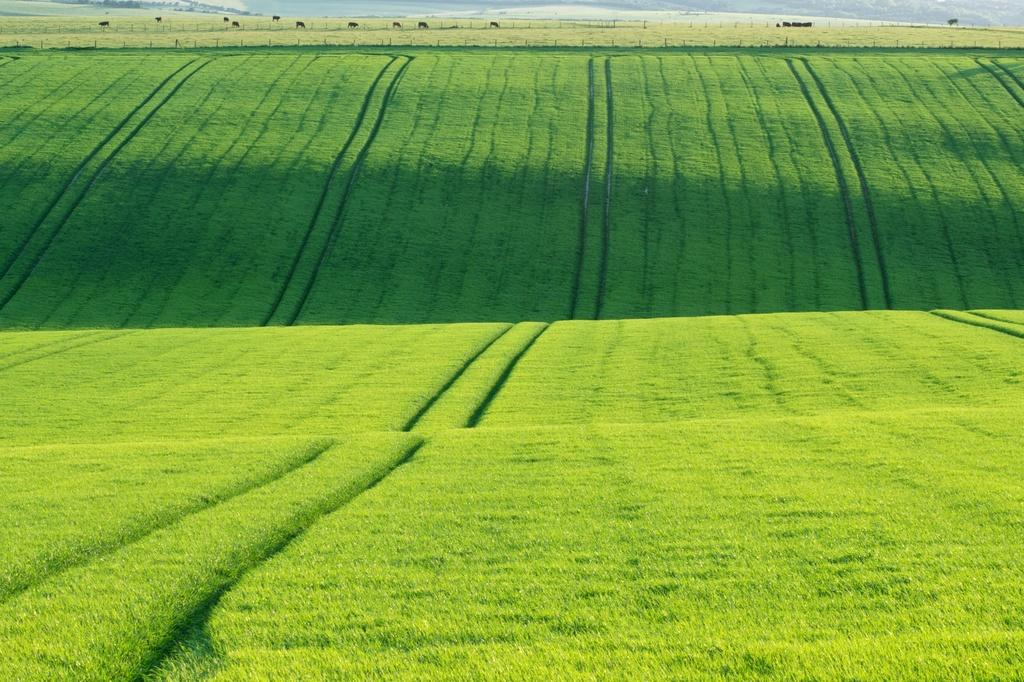What type of vegetation is visible in the image? There is grass in the image. What can be seen in the background of the image? There are animals and a fence in the background of the image. Are there any other objects visible in the background? Yes, there are other objects in the background of the image. What type of rhythm can be heard coming from the animals in the image? There is no sound or rhythm present in the image, as it is a still image. 